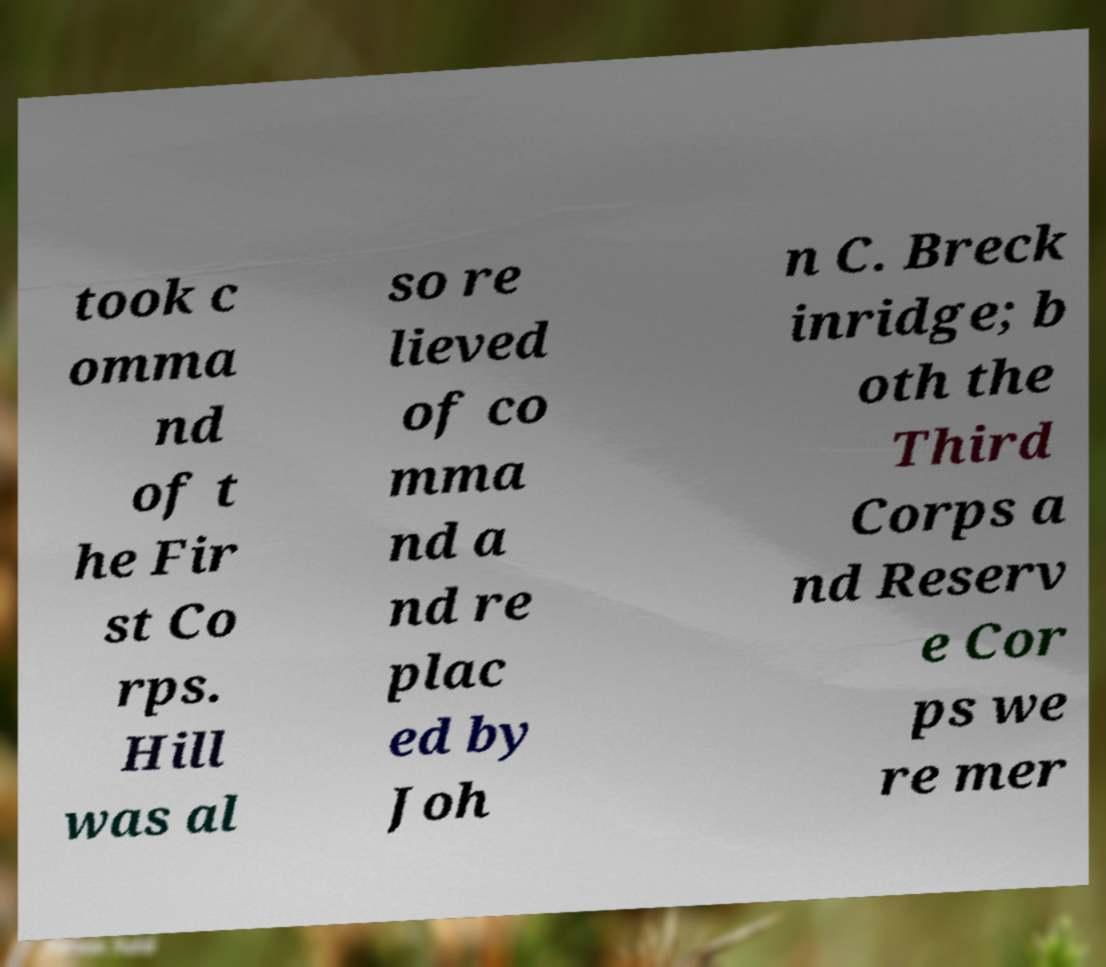There's text embedded in this image that I need extracted. Can you transcribe it verbatim? took c omma nd of t he Fir st Co rps. Hill was al so re lieved of co mma nd a nd re plac ed by Joh n C. Breck inridge; b oth the Third Corps a nd Reserv e Cor ps we re mer 